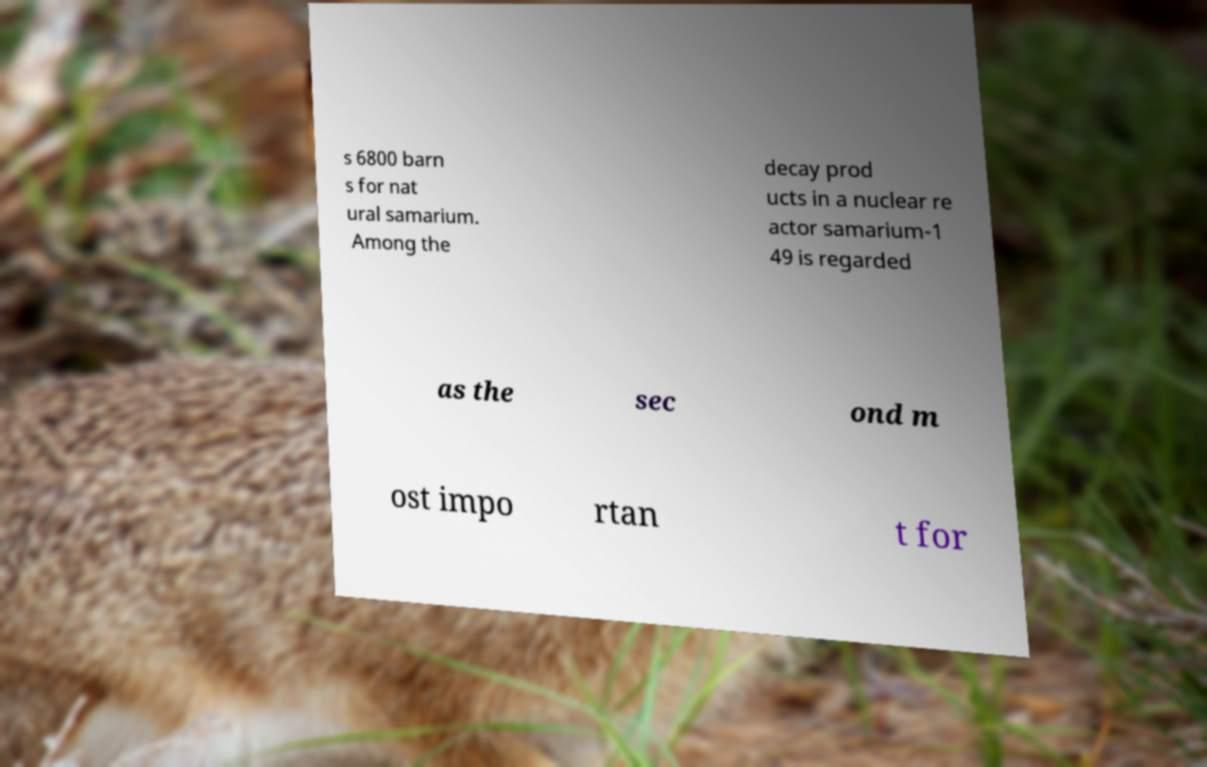Can you accurately transcribe the text from the provided image for me? s 6800 barn s for nat ural samarium. Among the decay prod ucts in a nuclear re actor samarium-1 49 is regarded as the sec ond m ost impo rtan t for 